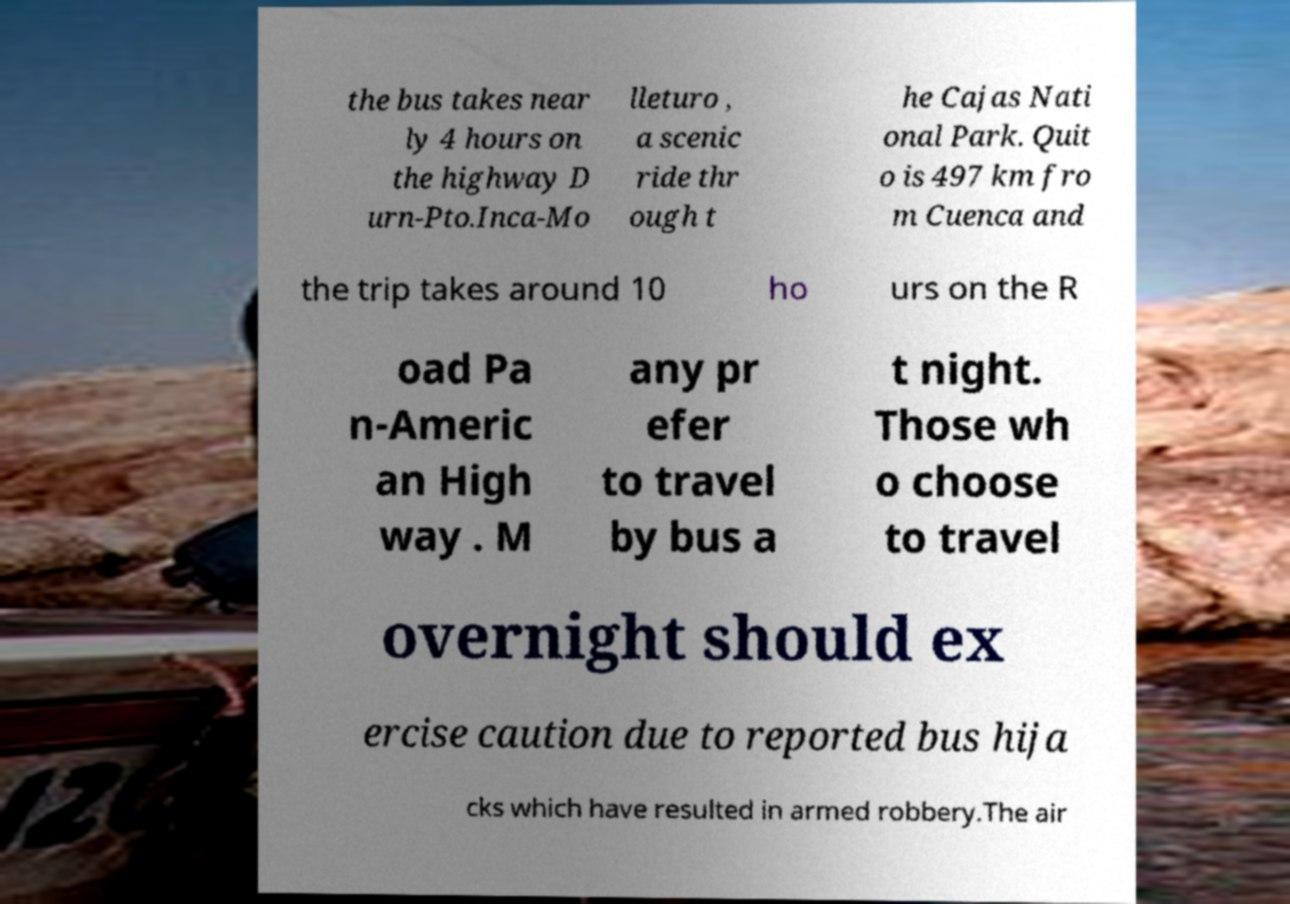What messages or text are displayed in this image? I need them in a readable, typed format. the bus takes near ly 4 hours on the highway D urn-Pto.Inca-Mo lleturo , a scenic ride thr ough t he Cajas Nati onal Park. Quit o is 497 km fro m Cuenca and the trip takes around 10 ho urs on the R oad Pa n-Americ an High way . M any pr efer to travel by bus a t night. Those wh o choose to travel overnight should ex ercise caution due to reported bus hija cks which have resulted in armed robbery.The air 